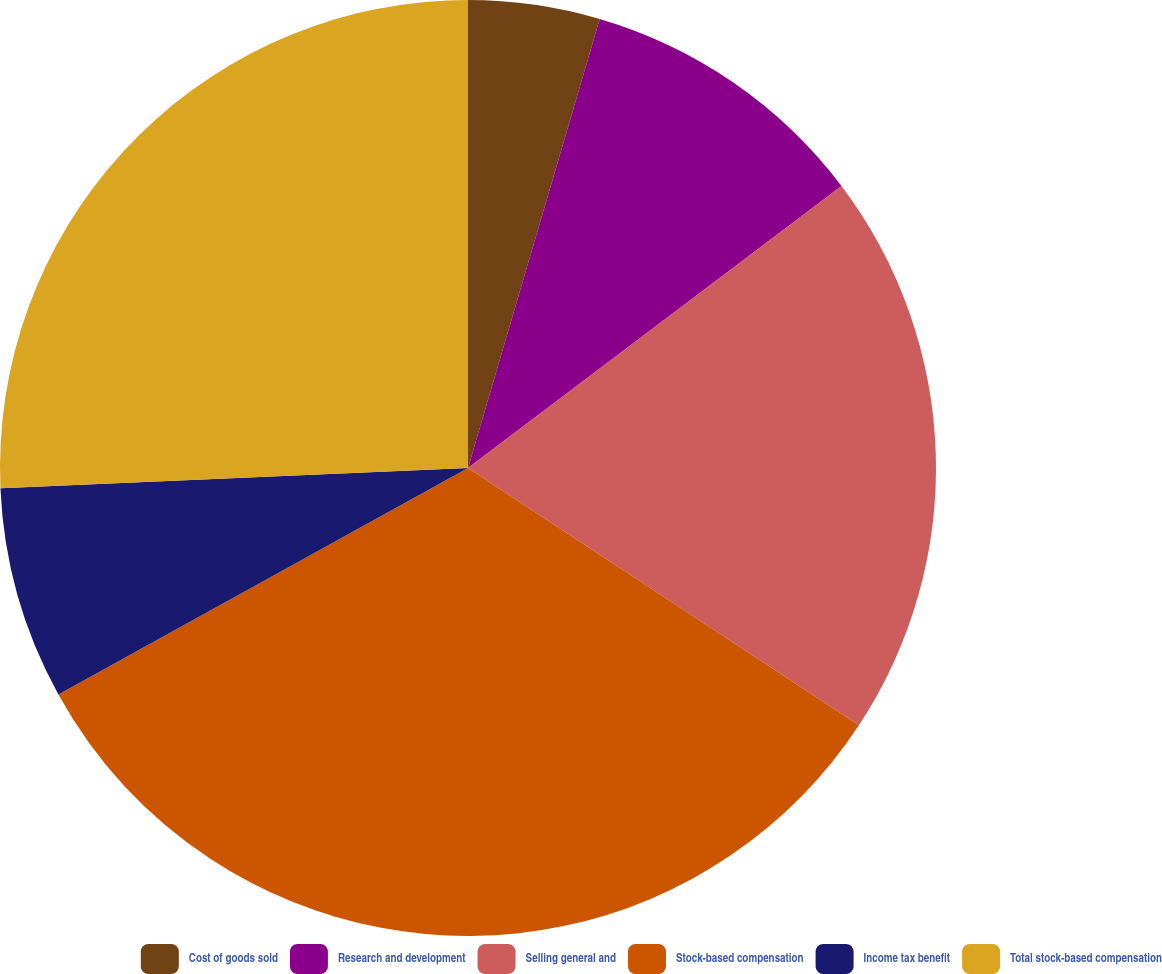Convert chart. <chart><loc_0><loc_0><loc_500><loc_500><pie_chart><fcel>Cost of goods sold<fcel>Research and development<fcel>Selling general and<fcel>Stock-based compensation<fcel>Income tax benefit<fcel>Total stock-based compensation<nl><fcel>4.54%<fcel>10.17%<fcel>19.56%<fcel>32.7%<fcel>7.35%<fcel>25.69%<nl></chart> 